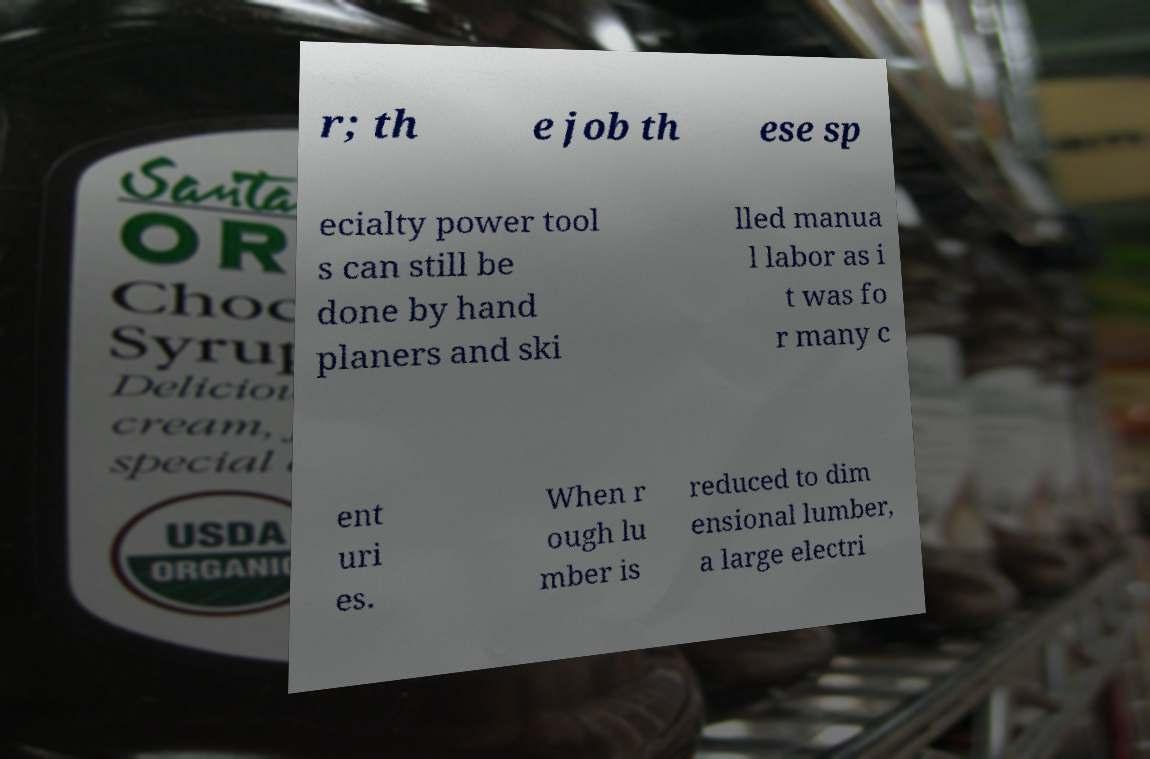Please identify and transcribe the text found in this image. r; th e job th ese sp ecialty power tool s can still be done by hand planers and ski lled manua l labor as i t was fo r many c ent uri es. When r ough lu mber is reduced to dim ensional lumber, a large electri 